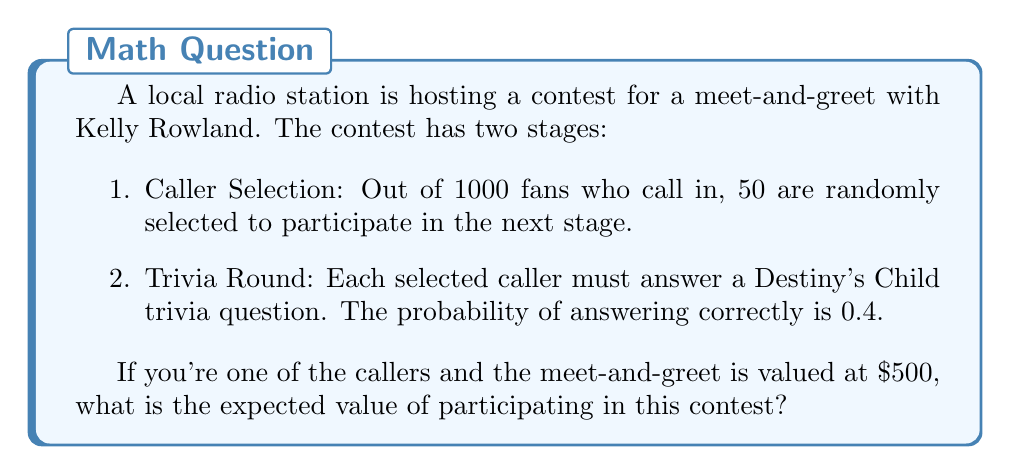Help me with this question. Let's break this down step-by-step:

1. Probability of being selected as a caller:
   $P(\text{selected}) = \frac{50}{1000} = 0.05$

2. Probability of answering the trivia question correctly:
   $P(\text{correct}) = 0.4$

3. Overall probability of winning the meet-and-greet:
   $P(\text{win}) = P(\text{selected}) \times P(\text{correct})$
   $P(\text{win}) = 0.05 \times 0.4 = 0.02$

4. Expected value calculation:
   The expected value is the probability of winning multiplied by the value of the prize.
   
   $E(\text{contest}) = P(\text{win}) \times \text{Value}$
   $E(\text{contest}) = 0.02 \times \$500 = \$10$

Therefore, the expected value of participating in this contest is $10.
Answer: $10 